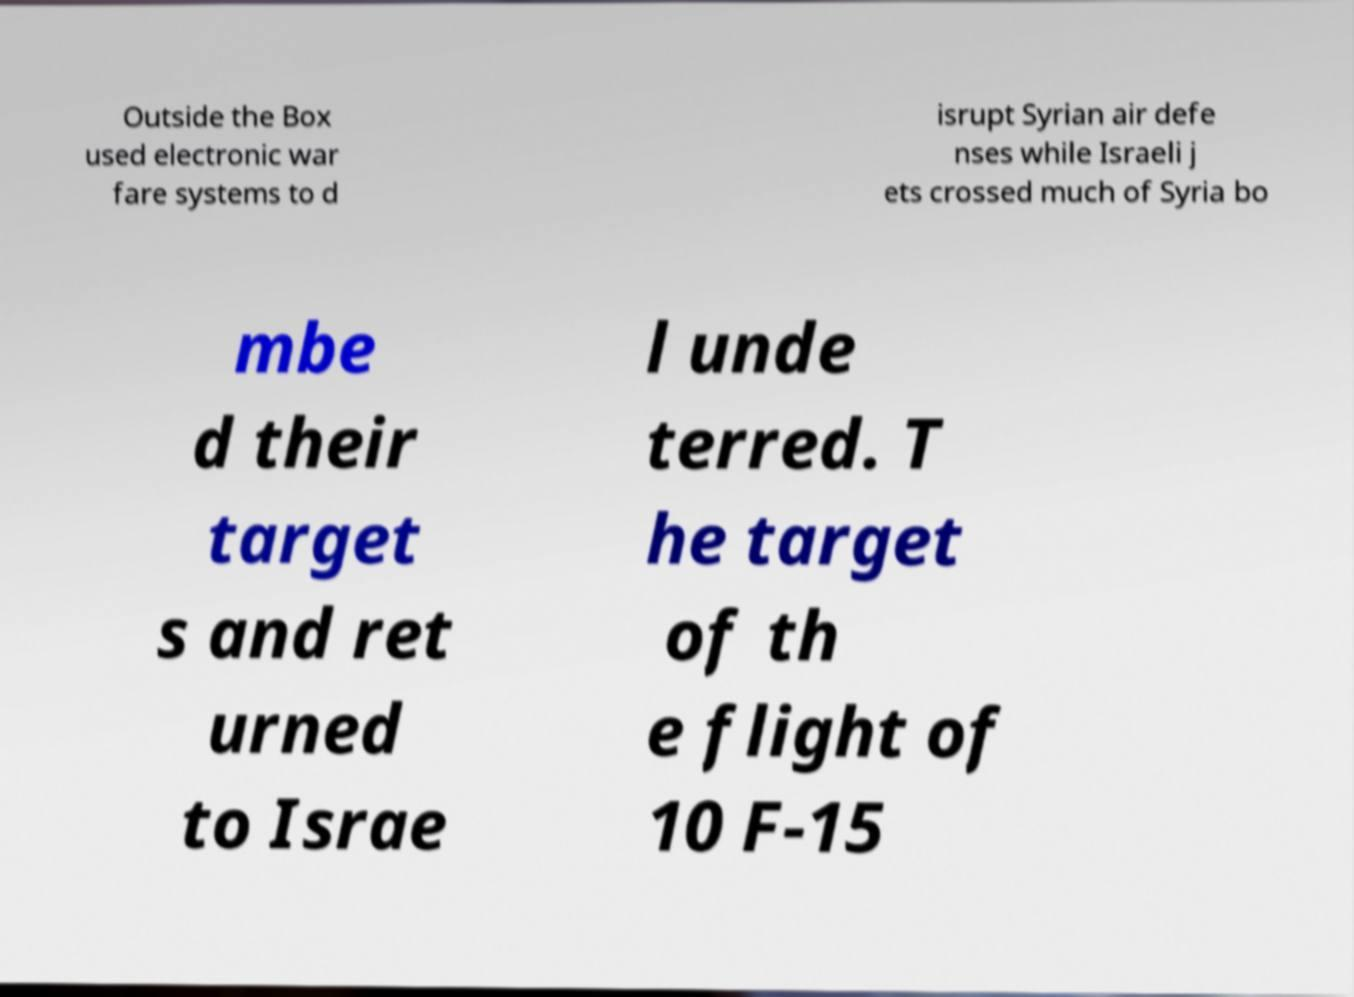Can you read and provide the text displayed in the image?This photo seems to have some interesting text. Can you extract and type it out for me? Outside the Box used electronic war fare systems to d isrupt Syrian air defe nses while Israeli j ets crossed much of Syria bo mbe d their target s and ret urned to Israe l unde terred. T he target of th e flight of 10 F-15 